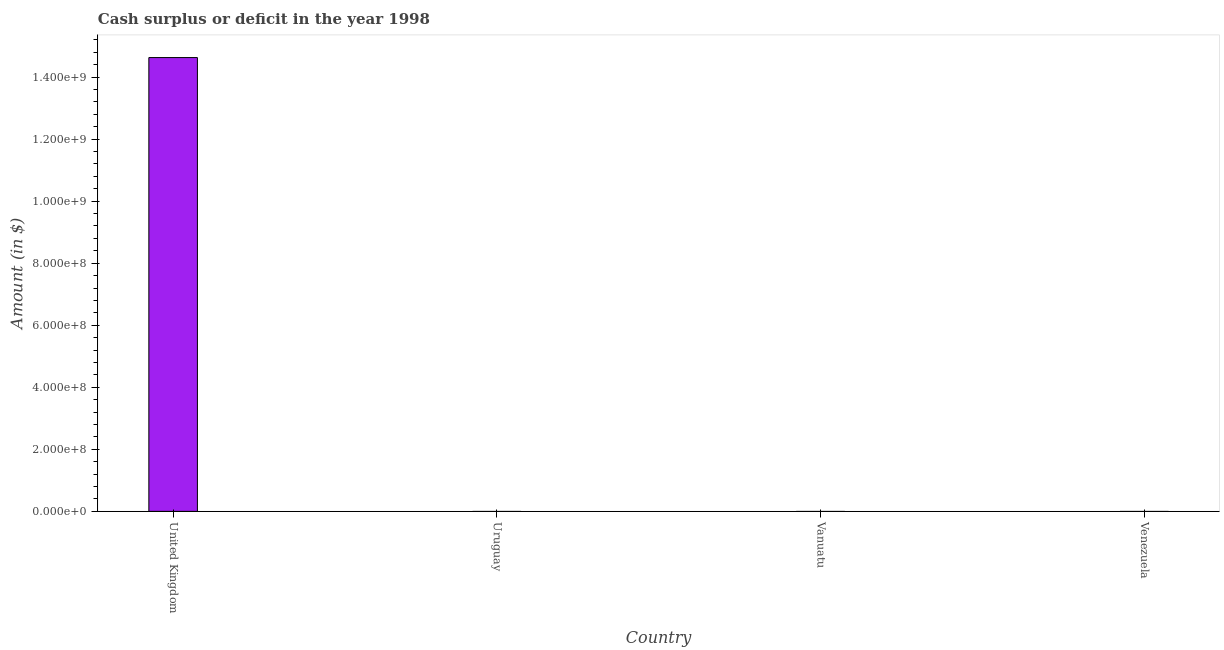Does the graph contain grids?
Make the answer very short. No. What is the title of the graph?
Your response must be concise. Cash surplus or deficit in the year 1998. What is the label or title of the X-axis?
Offer a terse response. Country. What is the label or title of the Y-axis?
Make the answer very short. Amount (in $). Across all countries, what is the maximum cash surplus or deficit?
Your response must be concise. 1.46e+09. Across all countries, what is the minimum cash surplus or deficit?
Ensure brevity in your answer.  0. What is the sum of the cash surplus or deficit?
Your answer should be compact. 1.46e+09. What is the average cash surplus or deficit per country?
Keep it short and to the point. 3.66e+08. What is the median cash surplus or deficit?
Your response must be concise. 0. What is the difference between the highest and the lowest cash surplus or deficit?
Give a very brief answer. 1.46e+09. In how many countries, is the cash surplus or deficit greater than the average cash surplus or deficit taken over all countries?
Offer a very short reply. 1. How many bars are there?
Provide a short and direct response. 1. Are all the bars in the graph horizontal?
Keep it short and to the point. No. What is the difference between two consecutive major ticks on the Y-axis?
Keep it short and to the point. 2.00e+08. Are the values on the major ticks of Y-axis written in scientific E-notation?
Your answer should be very brief. Yes. What is the Amount (in $) of United Kingdom?
Make the answer very short. 1.46e+09. What is the Amount (in $) in Uruguay?
Your answer should be very brief. 0. What is the Amount (in $) in Vanuatu?
Offer a very short reply. 0. What is the Amount (in $) of Venezuela?
Give a very brief answer. 0. 